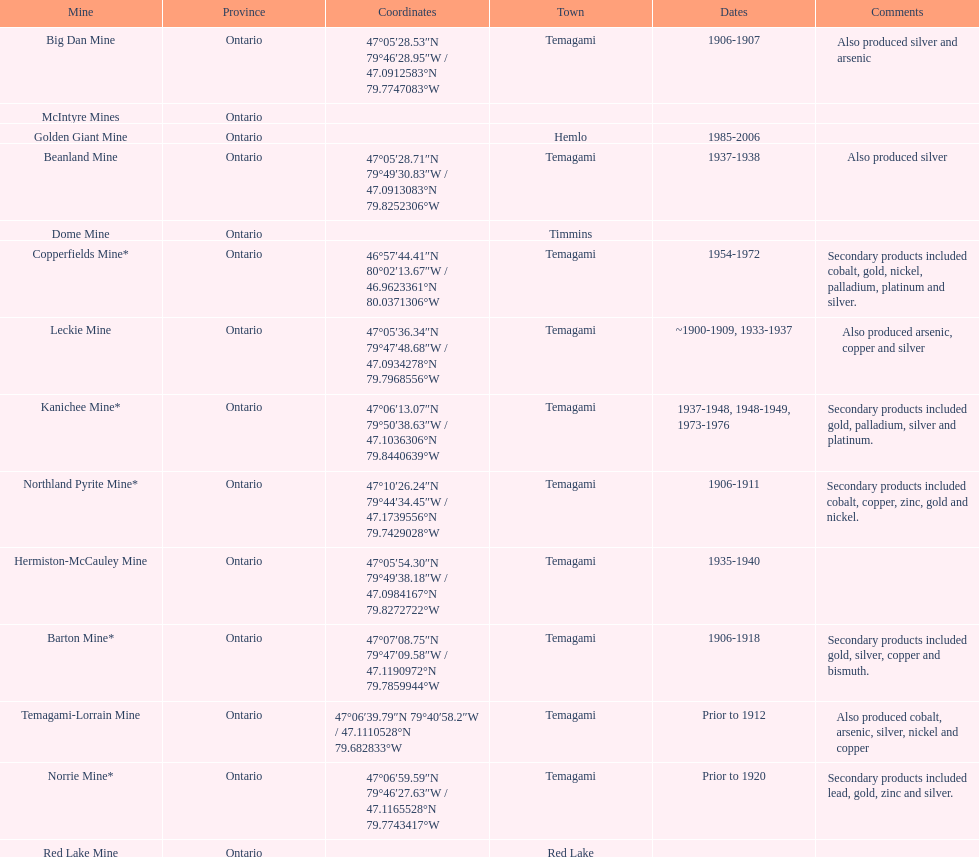What town is listed the most? Temagami. 